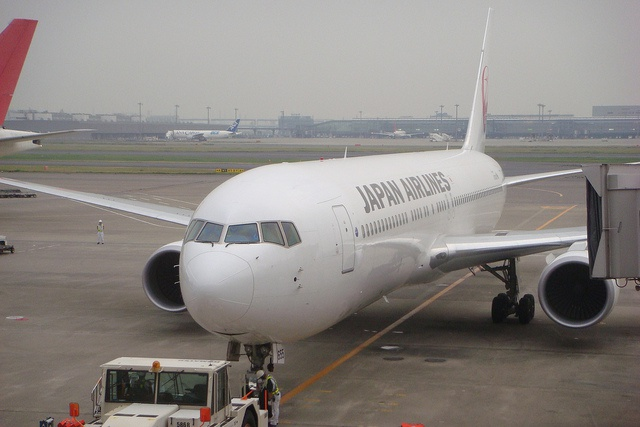Describe the objects in this image and their specific colors. I can see airplane in darkgray, lightgray, gray, and black tones, truck in darkgray, black, and gray tones, airplane in darkgray, brown, and gray tones, airplane in darkgray, lightgray, and gray tones, and people in darkgray, gray, black, darkgreen, and maroon tones in this image. 